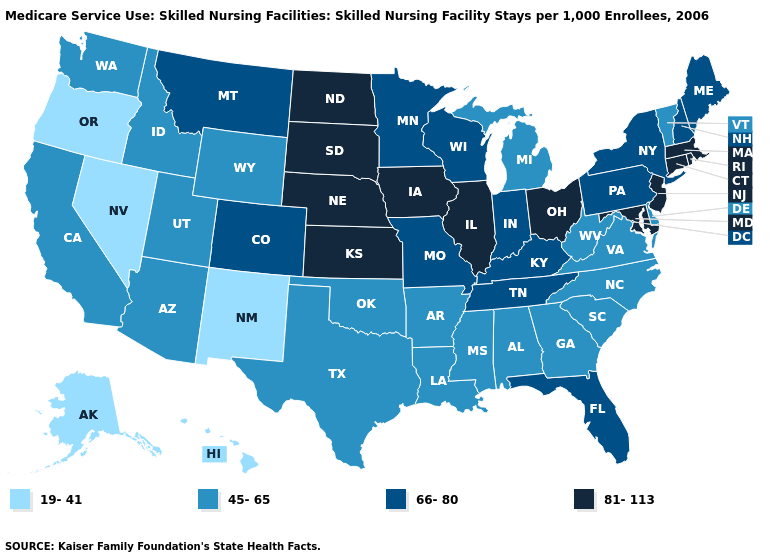What is the value of New York?
Quick response, please. 66-80. What is the value of Hawaii?
Write a very short answer. 19-41. Name the states that have a value in the range 45-65?
Write a very short answer. Alabama, Arizona, Arkansas, California, Delaware, Georgia, Idaho, Louisiana, Michigan, Mississippi, North Carolina, Oklahoma, South Carolina, Texas, Utah, Vermont, Virginia, Washington, West Virginia, Wyoming. Name the states that have a value in the range 19-41?
Be succinct. Alaska, Hawaii, Nevada, New Mexico, Oregon. Does North Carolina have the same value as Idaho?
Keep it brief. Yes. Which states have the highest value in the USA?
Keep it brief. Connecticut, Illinois, Iowa, Kansas, Maryland, Massachusetts, Nebraska, New Jersey, North Dakota, Ohio, Rhode Island, South Dakota. What is the lowest value in the USA?
Answer briefly. 19-41. Which states have the highest value in the USA?
Concise answer only. Connecticut, Illinois, Iowa, Kansas, Maryland, Massachusetts, Nebraska, New Jersey, North Dakota, Ohio, Rhode Island, South Dakota. Name the states that have a value in the range 81-113?
Answer briefly. Connecticut, Illinois, Iowa, Kansas, Maryland, Massachusetts, Nebraska, New Jersey, North Dakota, Ohio, Rhode Island, South Dakota. Does South Carolina have the lowest value in the USA?
Keep it brief. No. Which states have the highest value in the USA?
Give a very brief answer. Connecticut, Illinois, Iowa, Kansas, Maryland, Massachusetts, Nebraska, New Jersey, North Dakota, Ohio, Rhode Island, South Dakota. Name the states that have a value in the range 45-65?
Give a very brief answer. Alabama, Arizona, Arkansas, California, Delaware, Georgia, Idaho, Louisiana, Michigan, Mississippi, North Carolina, Oklahoma, South Carolina, Texas, Utah, Vermont, Virginia, Washington, West Virginia, Wyoming. Name the states that have a value in the range 19-41?
Keep it brief. Alaska, Hawaii, Nevada, New Mexico, Oregon. Name the states that have a value in the range 81-113?
Concise answer only. Connecticut, Illinois, Iowa, Kansas, Maryland, Massachusetts, Nebraska, New Jersey, North Dakota, Ohio, Rhode Island, South Dakota. 